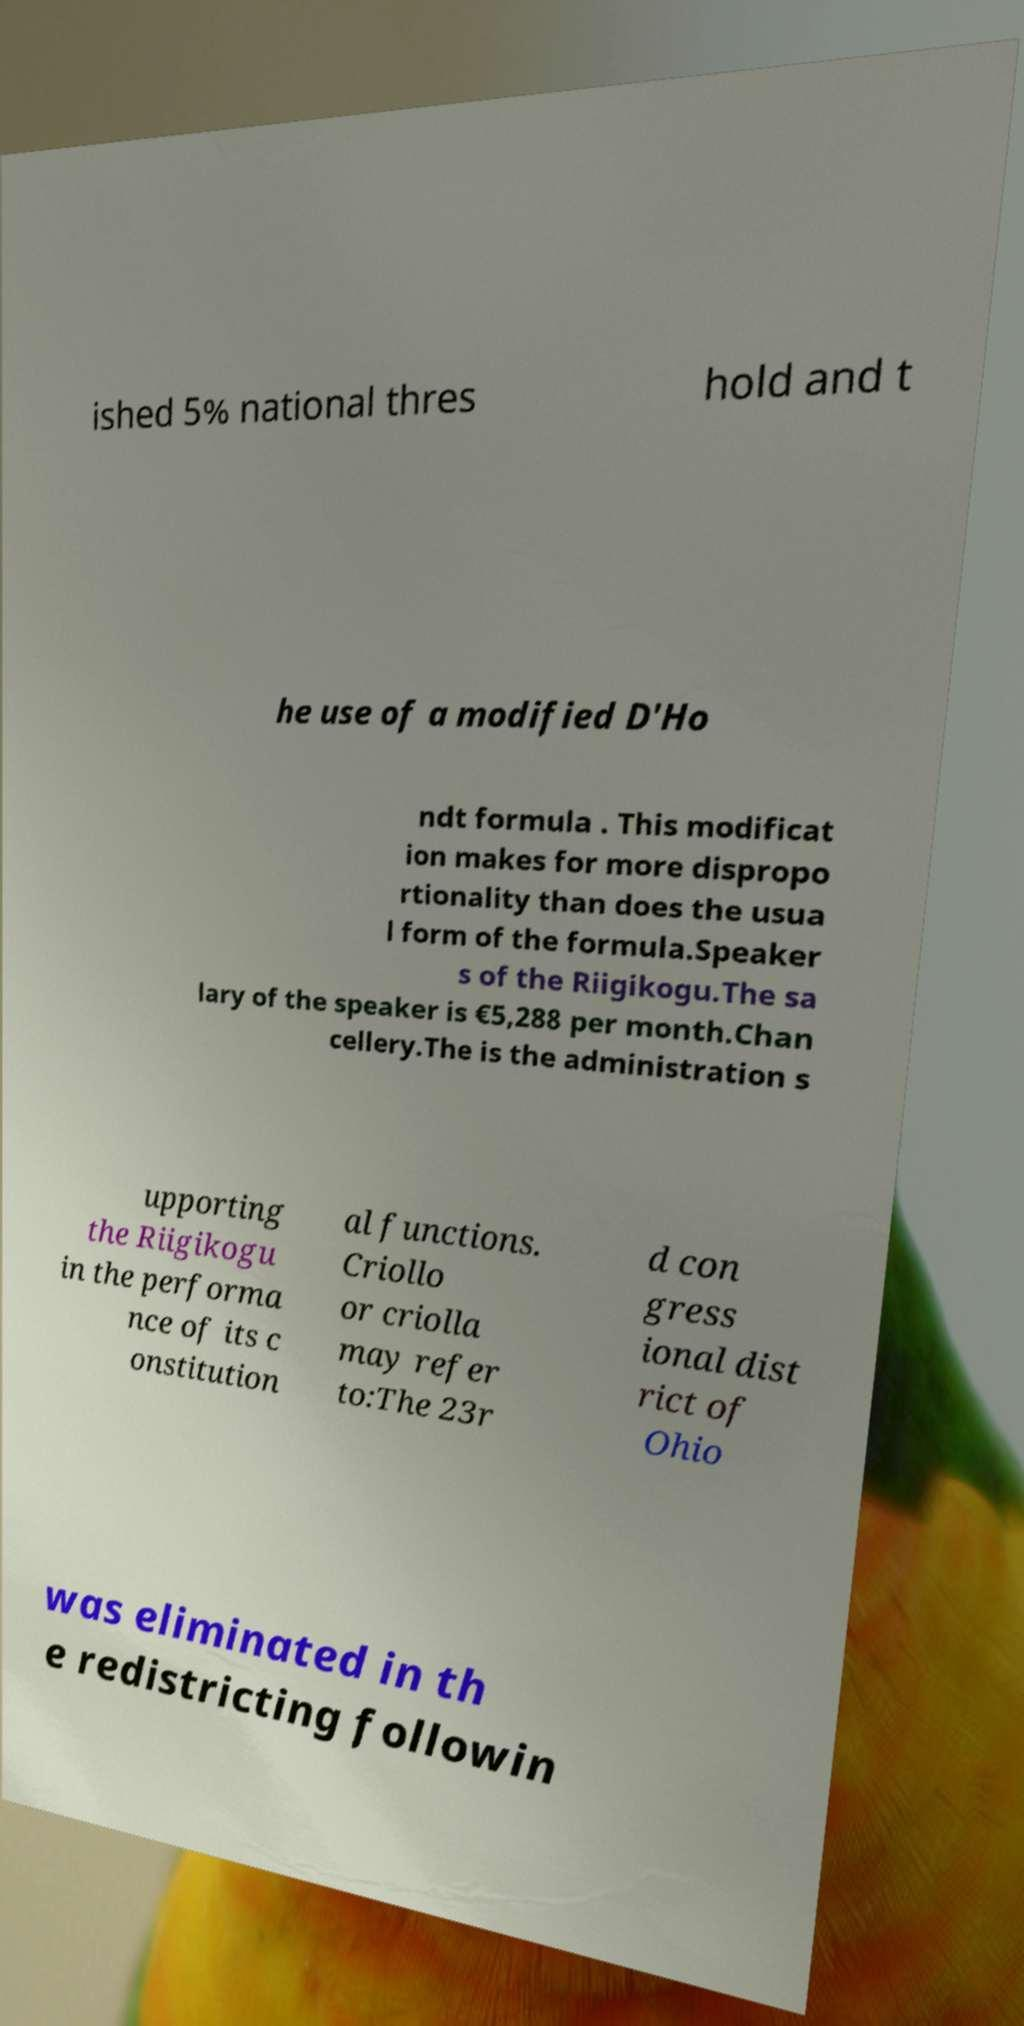Please read and relay the text visible in this image. What does it say? ished 5% national thres hold and t he use of a modified D'Ho ndt formula . This modificat ion makes for more dispropo rtionality than does the usua l form of the formula.Speaker s of the Riigikogu.The sa lary of the speaker is €5,288 per month.Chan cellery.The is the administration s upporting the Riigikogu in the performa nce of its c onstitution al functions. Criollo or criolla may refer to:The 23r d con gress ional dist rict of Ohio was eliminated in th e redistricting followin 